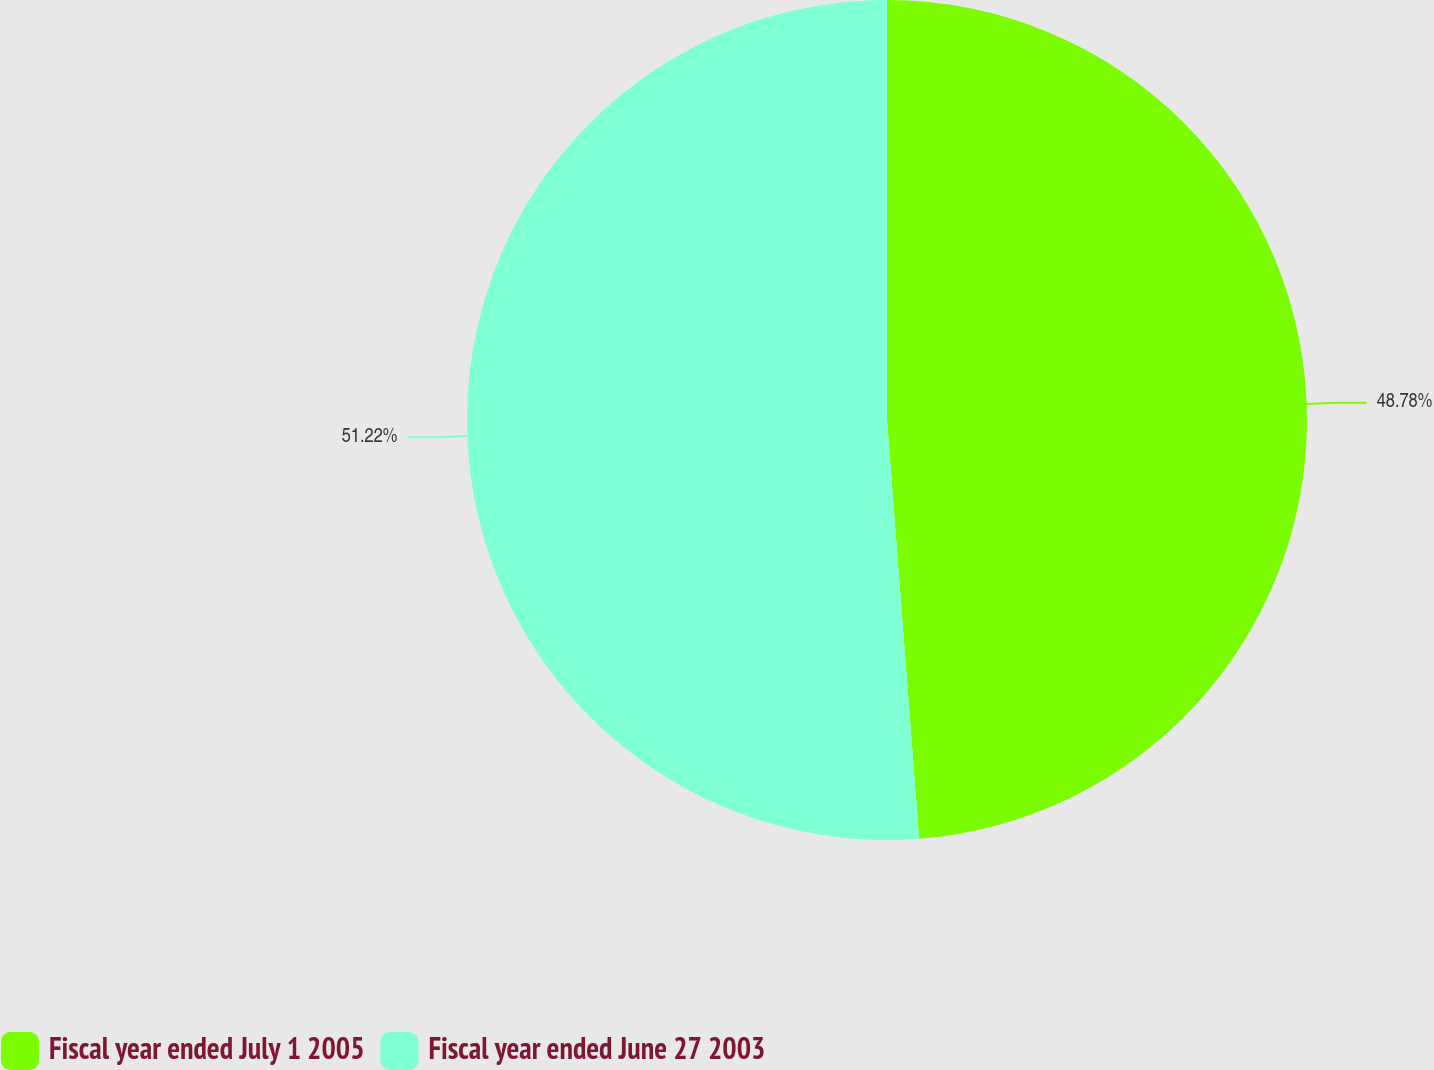Convert chart. <chart><loc_0><loc_0><loc_500><loc_500><pie_chart><fcel>Fiscal year ended July 1 2005<fcel>Fiscal year ended June 27 2003<nl><fcel>48.78%<fcel>51.22%<nl></chart> 